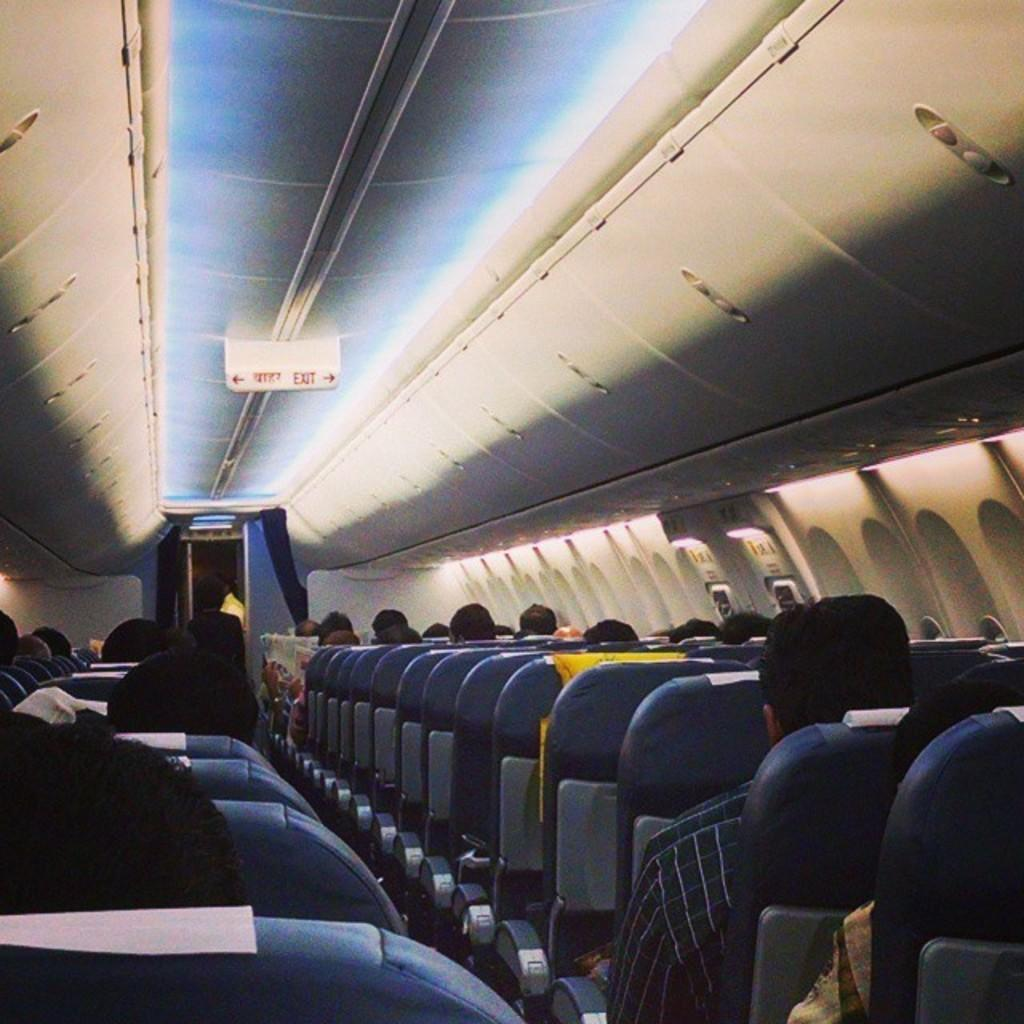Provide a one-sentence caption for the provided image. the word exit is on the roof of the plane. 